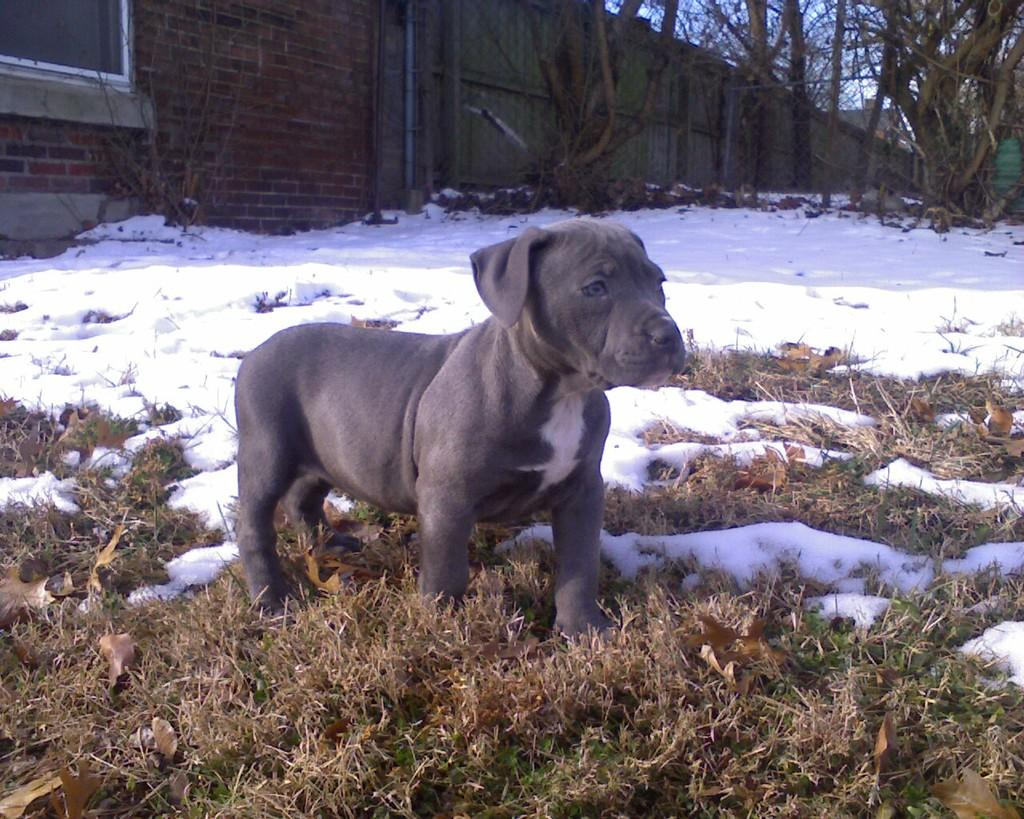What type of animal is in the image? There is a dog in the image. What color is the dog? The dog is black in color. What is the weather like in the image? There is snow in the image, indicating a cold and likely wintery environment. What can be seen in the background of the image? There are houses and trees in the background of the image, as well as a clear sky. How does the dog wave its finger in the image? There is no indication in the image that the dog is waving its finger or any other body part. 